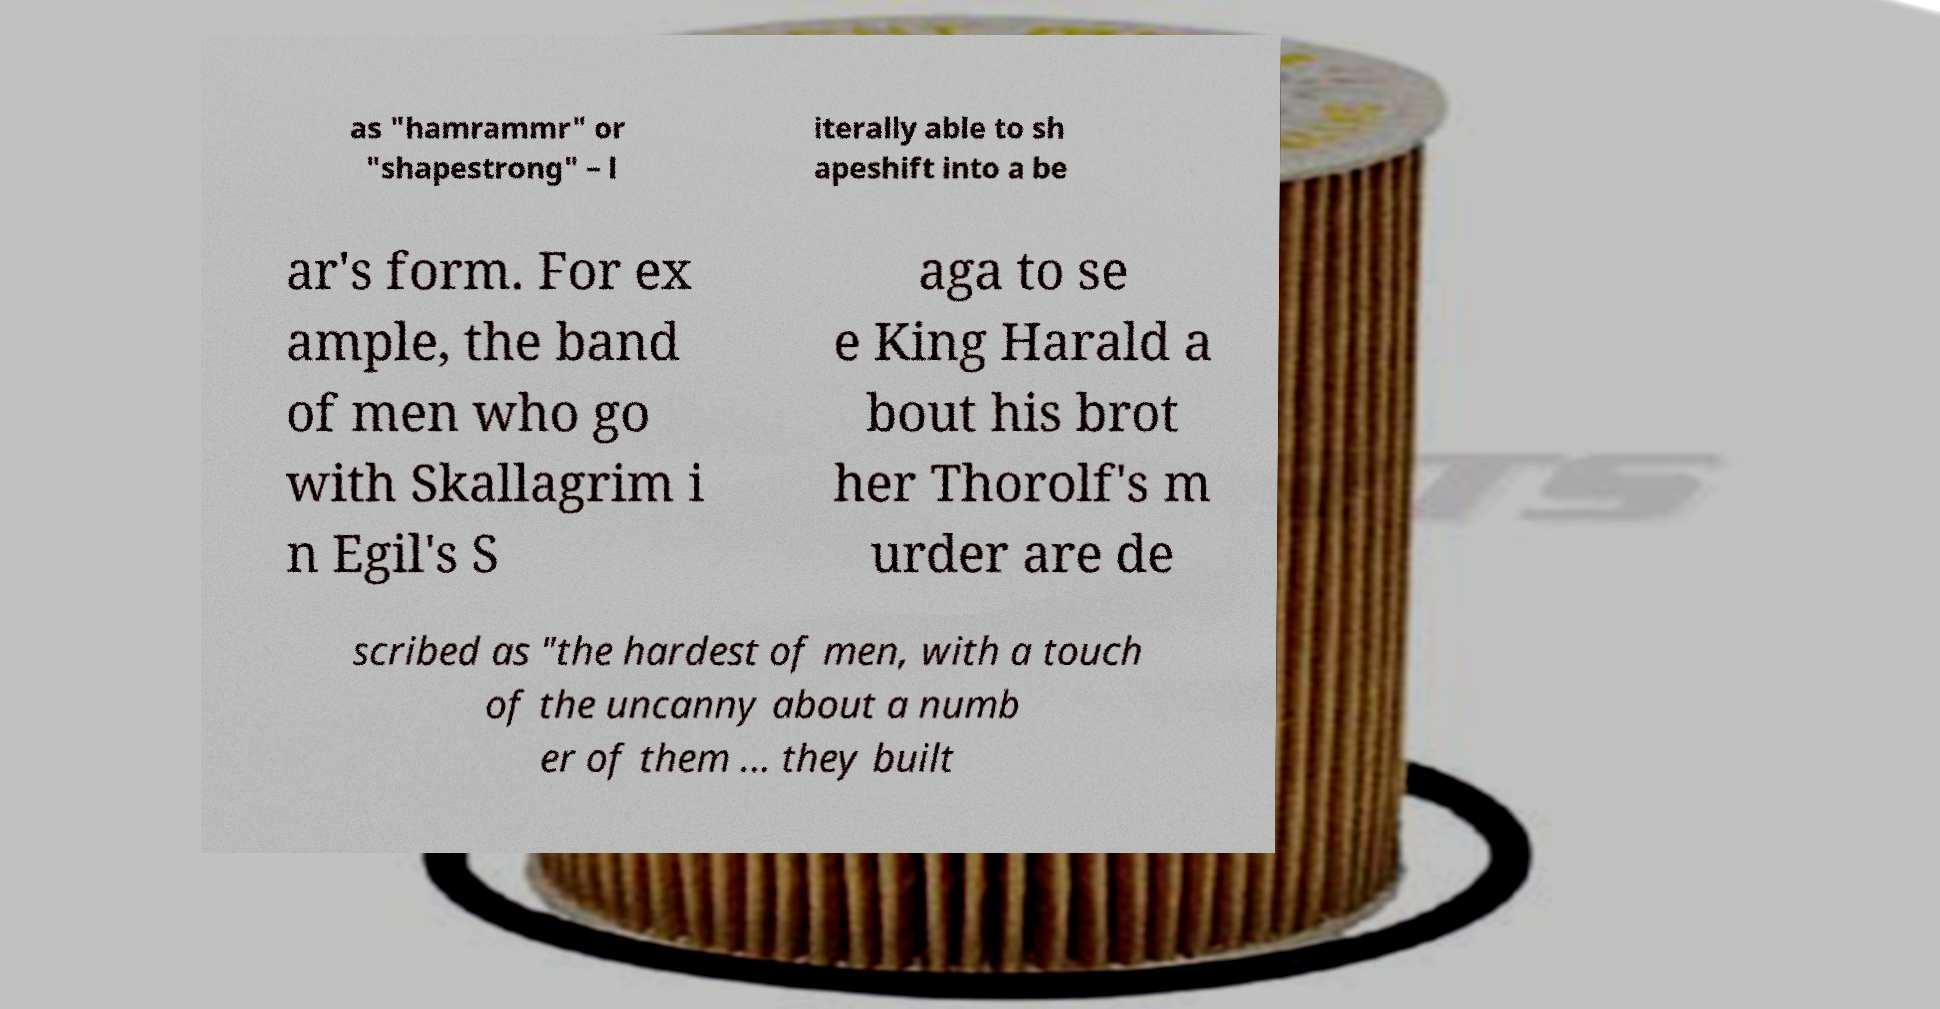Could you extract and type out the text from this image? as "hamrammr" or "shapestrong" – l iterally able to sh apeshift into a be ar's form. For ex ample, the band of men who go with Skallagrim i n Egil's S aga to se e King Harald a bout his brot her Thorolf's m urder are de scribed as "the hardest of men, with a touch of the uncanny about a numb er of them ... they built 